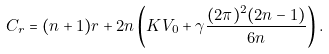<formula> <loc_0><loc_0><loc_500><loc_500>C _ { r } = ( n + 1 ) r + 2 n \left ( K V _ { 0 } + \gamma \frac { ( 2 \pi ) ^ { 2 } ( 2 n - 1 ) } { 6 n } \right ) .</formula> 